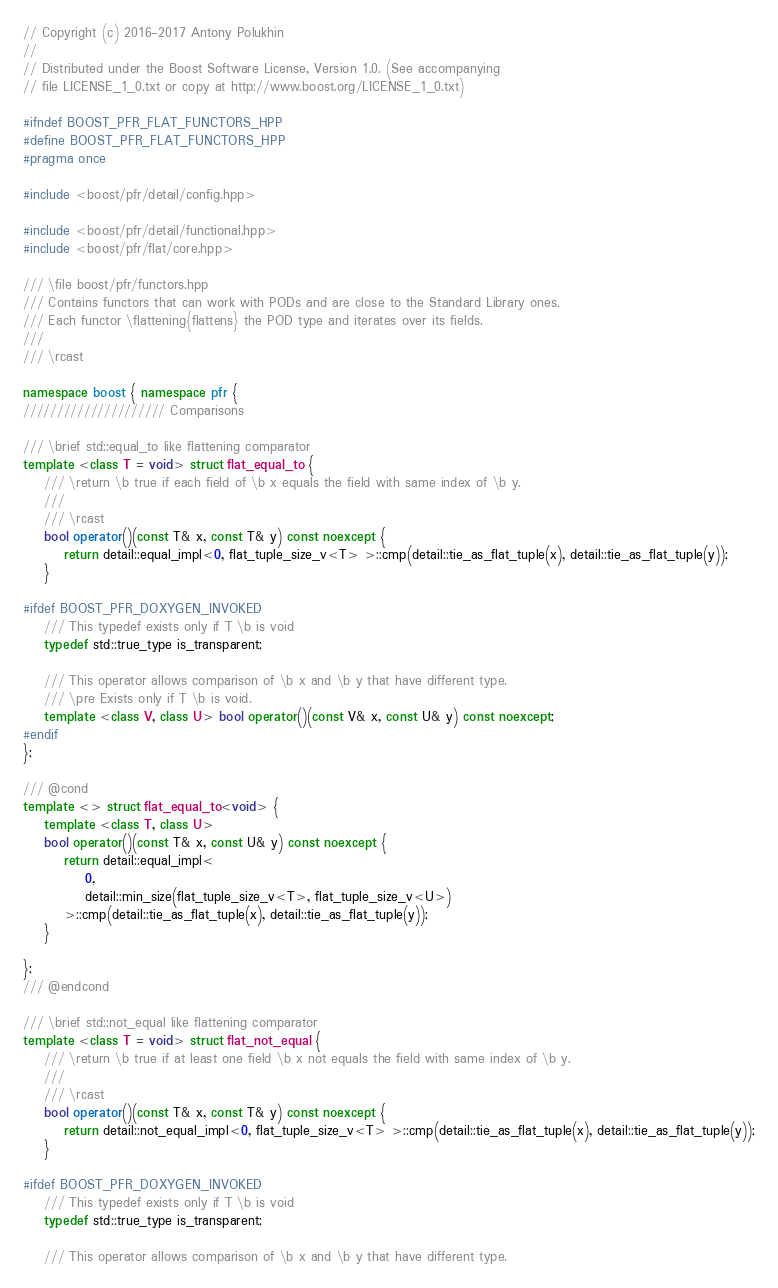Convert code to text. <code><loc_0><loc_0><loc_500><loc_500><_C++_>// Copyright (c) 2016-2017 Antony Polukhin
//
// Distributed under the Boost Software License, Version 1.0. (See accompanying
// file LICENSE_1_0.txt or copy at http://www.boost.org/LICENSE_1_0.txt)

#ifndef BOOST_PFR_FLAT_FUNCTORS_HPP
#define BOOST_PFR_FLAT_FUNCTORS_HPP
#pragma once

#include <boost/pfr/detail/config.hpp>

#include <boost/pfr/detail/functional.hpp>
#include <boost/pfr/flat/core.hpp>

/// \file boost/pfr/functors.hpp
/// Contains functors that can work with PODs and are close to the Standard Library ones.
/// Each functor \flattening{flattens} the POD type and iterates over its fields.
///
/// \rcast

namespace boost { namespace pfr {
///////////////////// Comparisons

/// \brief std::equal_to like flattening comparator
template <class T = void> struct flat_equal_to {
    /// \return \b true if each field of \b x equals the field with same index of \b y.
    ///
    /// \rcast
    bool operator()(const T& x, const T& y) const noexcept {
        return detail::equal_impl<0, flat_tuple_size_v<T> >::cmp(detail::tie_as_flat_tuple(x), detail::tie_as_flat_tuple(y));
    }

#ifdef BOOST_PFR_DOXYGEN_INVOKED
    /// This typedef exists only if T \b is void
    typedef std::true_type is_transparent;

    /// This operator allows comparison of \b x and \b y that have different type.
    /// \pre Exists only if T \b is void.
    template <class V, class U> bool operator()(const V& x, const U& y) const noexcept;
#endif
};

/// @cond
template <> struct flat_equal_to<void> {
    template <class T, class U>
    bool operator()(const T& x, const U& y) const noexcept {
        return detail::equal_impl<
            0,
            detail::min_size(flat_tuple_size_v<T>, flat_tuple_size_v<U>)
        >::cmp(detail::tie_as_flat_tuple(x), detail::tie_as_flat_tuple(y));
    }

};
/// @endcond

/// \brief std::not_equal like flattening comparator
template <class T = void> struct flat_not_equal {
    /// \return \b true if at least one field \b x not equals the field with same index of \b y.
    ///
    /// \rcast
    bool operator()(const T& x, const T& y) const noexcept {
        return detail::not_equal_impl<0, flat_tuple_size_v<T> >::cmp(detail::tie_as_flat_tuple(x), detail::tie_as_flat_tuple(y));
    }

#ifdef BOOST_PFR_DOXYGEN_INVOKED
    /// This typedef exists only if T \b is void
    typedef std::true_type is_transparent;

    /// This operator allows comparison of \b x and \b y that have different type.</code> 